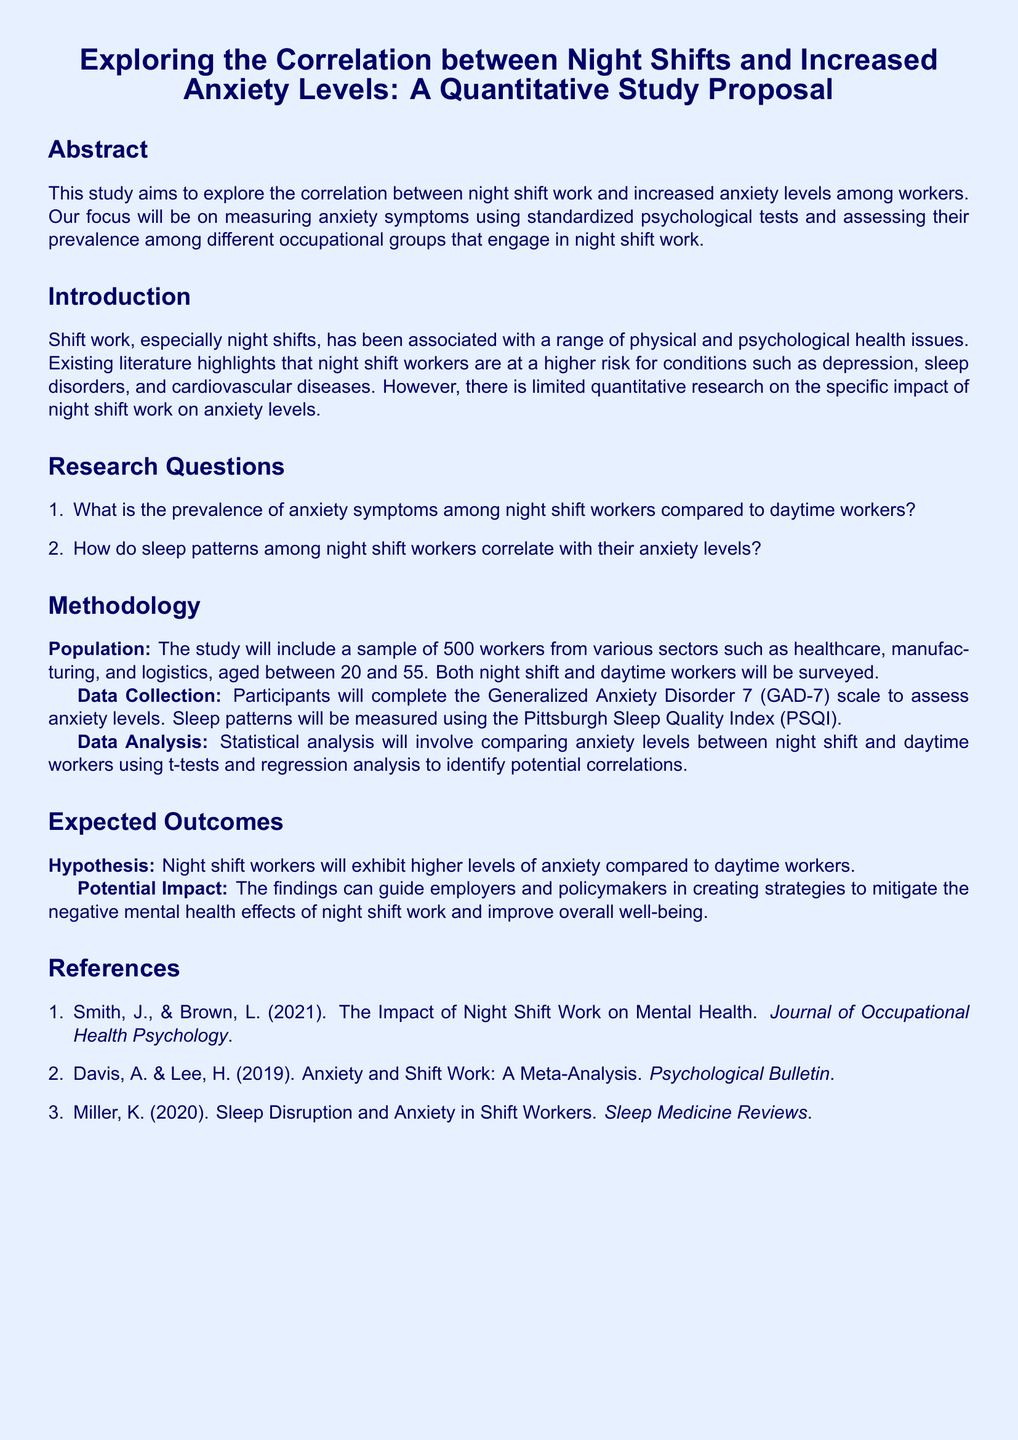What is the primary focus of the study? The study focuses on measuring anxiety symptoms and assessing their prevalence among different occupational groups that engage in night shift work.
Answer: measuring anxiety symptoms What is the sample size for the study? The document states that the study will include a sample of 500 workers.
Answer: 500 workers What psychological test will be used to assess anxiety levels? The Generalized Anxiety Disorder 7 (GAD-7) scale will be used to assess anxiety levels.
Answer: GAD-7 What sector is NOT mentioned in the population for the study? The sectors mentioned include healthcare, manufacturing, and logistics, but there is no mention of agriculture.
Answer: agriculture What is the expected hypothesis regarding anxiety levels in night shift workers? The hypothesis expects that night shift workers will exhibit higher levels of anxiety compared to daytime workers.
Answer: higher levels of anxiety Which index will measure sleep patterns? The sleep patterns will be measured using the Pittsburgh Sleep Quality Index (PSQI).
Answer: PSQI How will data analysis compare anxiety levels? Statistical analysis will involve comparing anxiety levels using t-tests and regression analysis.
Answer: t-tests and regression analysis What is the timeframe of the participant age range for the study? The document mentions that participants will be aged between 20 and 55.
Answer: 20 and 55 Which reference discusses the impact of night shift work on mental health? The reference that discusses this impact is by Smith and Brown published in 2021.
Answer: Smith, J., & Brown, L. (2021) 